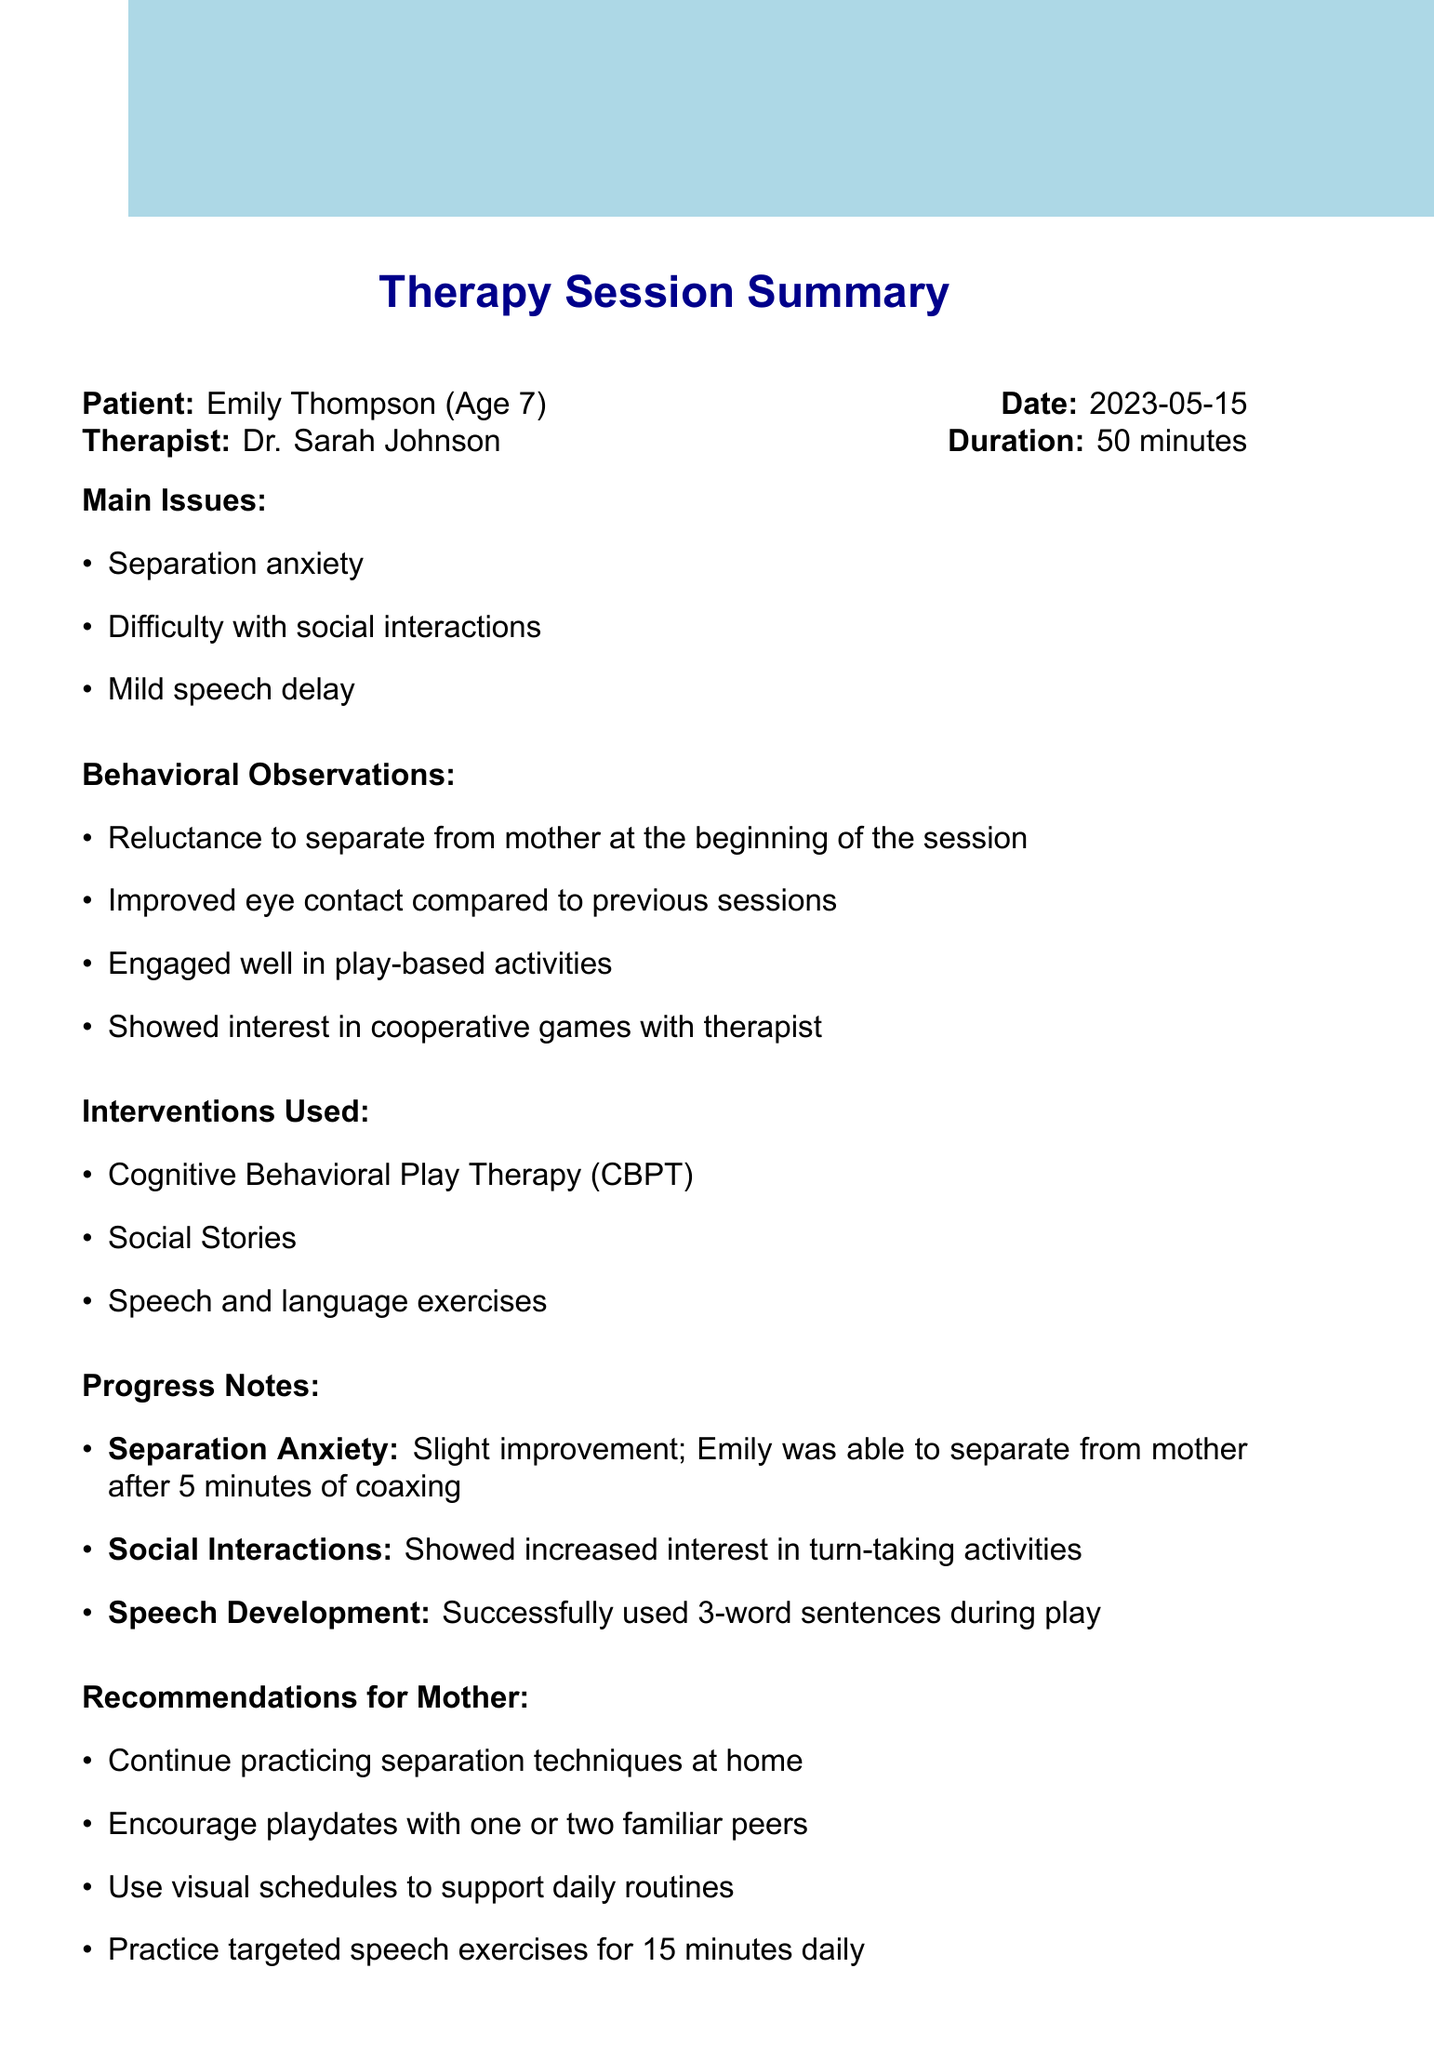What is the patient's name? The patient's name is listed at the beginning of the document under session summary.
Answer: Emily Thompson What is the age of the patient? The age of the patient is specified along with the name in the session summary.
Answer: 7 Who is the therapist? The therapist's name is mentioned in the session summary near the patient's details.
Answer: Dr. Sarah Johnson What was the duration of the therapy session? The duration is indicated in the session summary.
Answer: 50 minutes What is one main issue Emily is facing? One of the main issues is listed in the session summary under main issues.
Answer: Separation anxiety How much time did it take for Emily to separate from her mother? This detail is found in the progress notes under separation anxiety.
Answer: 5 minutes What type of therapy was used during the session? The types of interventions used are listed in the interventions section.
Answer: Cognitive Behavioral Play Therapy (CBPT) What is one recommendation for Emily’s mother? Recommendations for the mother are highlighted in a specific section of the document.
Answer: Continue practicing separation techniques at home What is the date of the next session? The date of the next session is mentioned under the next steps section.
Answer: 2023-05-22 What is one short-term goal for Emily? Short-term goals are listed in the next steps, outlining objectives for Emily's progress.
Answer: Reduce separation time to 2 minutes 